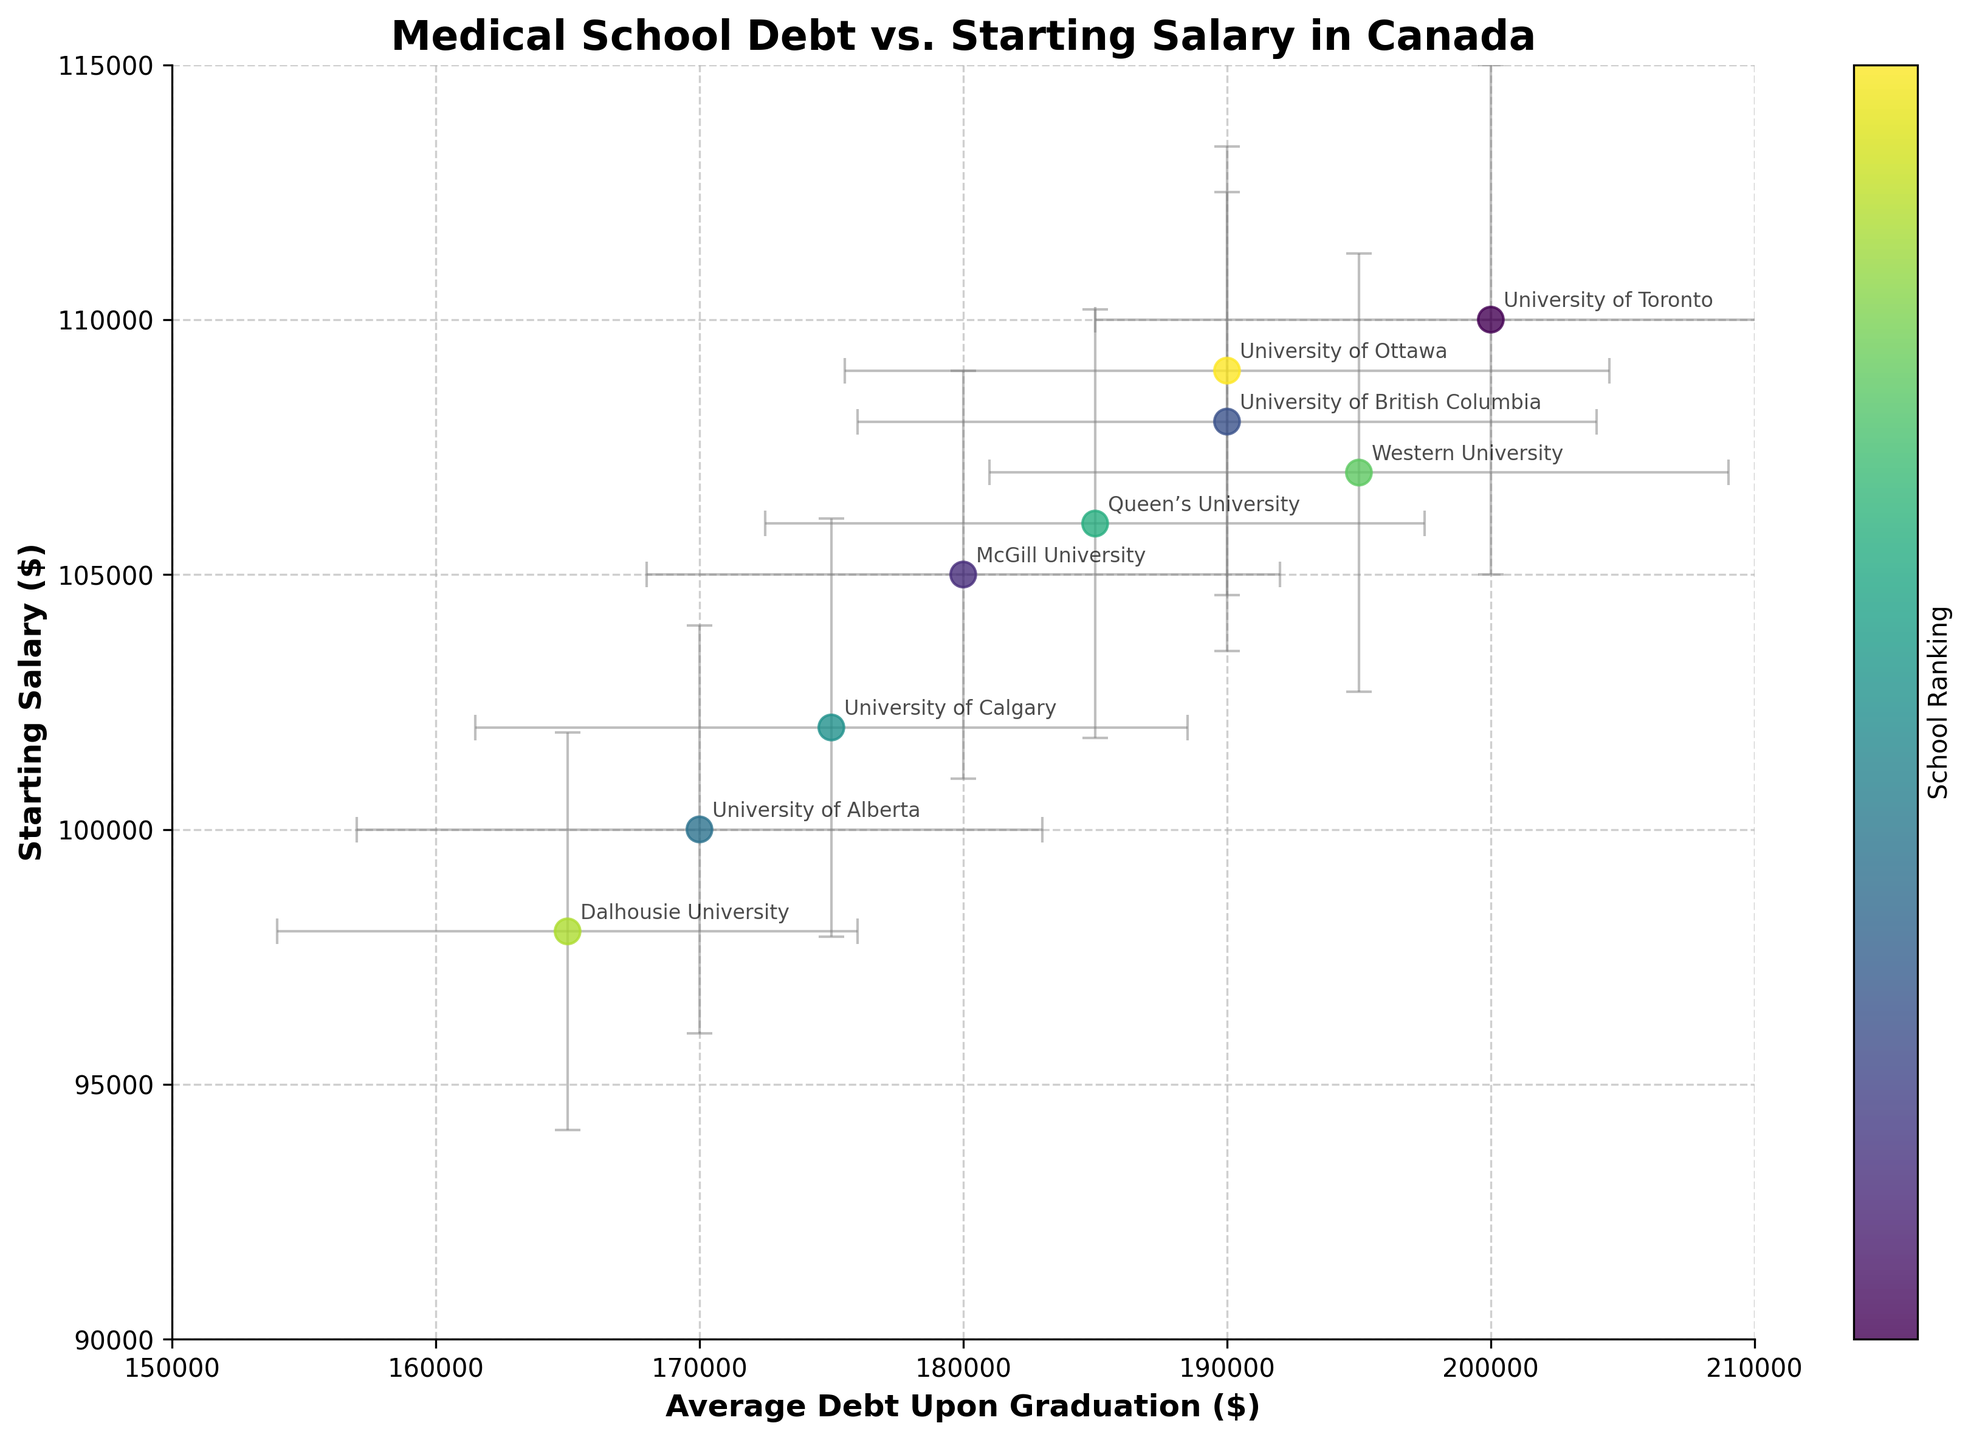what is the title of the figure? The title of the figure is usually displayed at the top and summarizes the main topic of the plot. Here, the title is "Medical School Debt vs. Starting Salary in Canada".
Answer: Medical School Debt vs. Starting Salary in Canada how many schools are represented in the figure? By counting the number of unique data points (or annotated school names), we can see there are 9 schools represented in the scatter plot.
Answer: 9 which school has the highest starting salary? By looking at the highest point along the y-axis (Starting Salary), the University of Toronto is at the highest position.
Answer: University of Toronto which school has the lowest average debt upon graduation? By looking at the leftmost position along the x-axis (Average Debt Upon Graduation), Dalhousie University is at the lowest position.
Answer: Dalhousie University how does the starting salary compare between McGill University and the University of Alberta? McGill University has a starting salary of $105,000, while the University of Alberta has a starting salary of $100,000. Since $105,000 is greater than $100,000, McGill University has a higher starting salary than the University of Alberta.
Answer: McGill University has a higher starting salary which school has the largest error in average debt upon graduation? By looking at the error bars length along the x-axis for each school, University of Toronto has the largest error bar, which is $15,000.
Answer: University of Toronto what is the average starting salary across all schools? To calculate the average starting salary, sum up all starting salaries and divide by the number of schools: (110,000 + 105,000 + 108,000 + 100,000 + 102,000 + 106,000 + 107,000 + 98,000 + 109,000) / 9 = 945,000 / 9 = 105,000.
Answer: $105,000 between University of Calgary and Queen’s University, which school has a smaller starting salary error? University of Calgary has a starting salary error of $4,100, while Queen’s University has a starting salary error of $4,200. Since $4,100 is smaller than $4,200, University of Calgary has a smaller starting salary error.
Answer: University of Calgary 